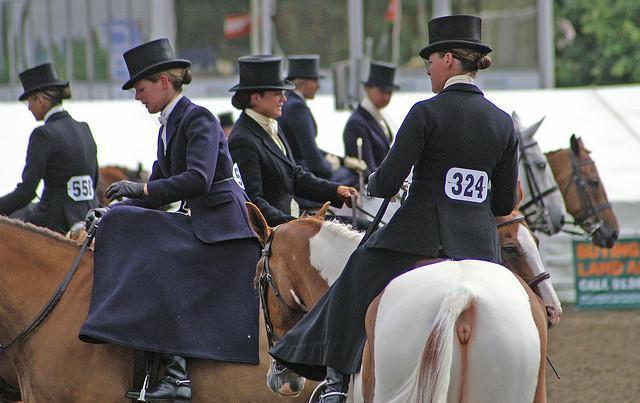How many people are there?
Give a very brief answer. 6. How many horses are in the photo?
Give a very brief answer. 6. How many clocks are showing?
Give a very brief answer. 0. 